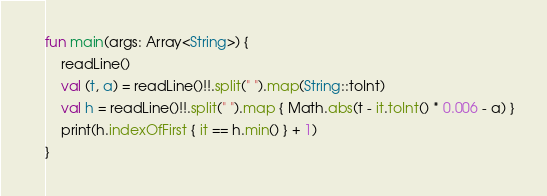<code> <loc_0><loc_0><loc_500><loc_500><_Kotlin_>fun main(args: Array<String>) {
    readLine()
    val (t, a) = readLine()!!.split(" ").map(String::toInt)
    val h = readLine()!!.split(" ").map { Math.abs(t - it.toInt() * 0.006 - a) }
    print(h.indexOfFirst { it == h.min() } + 1)
}</code> 